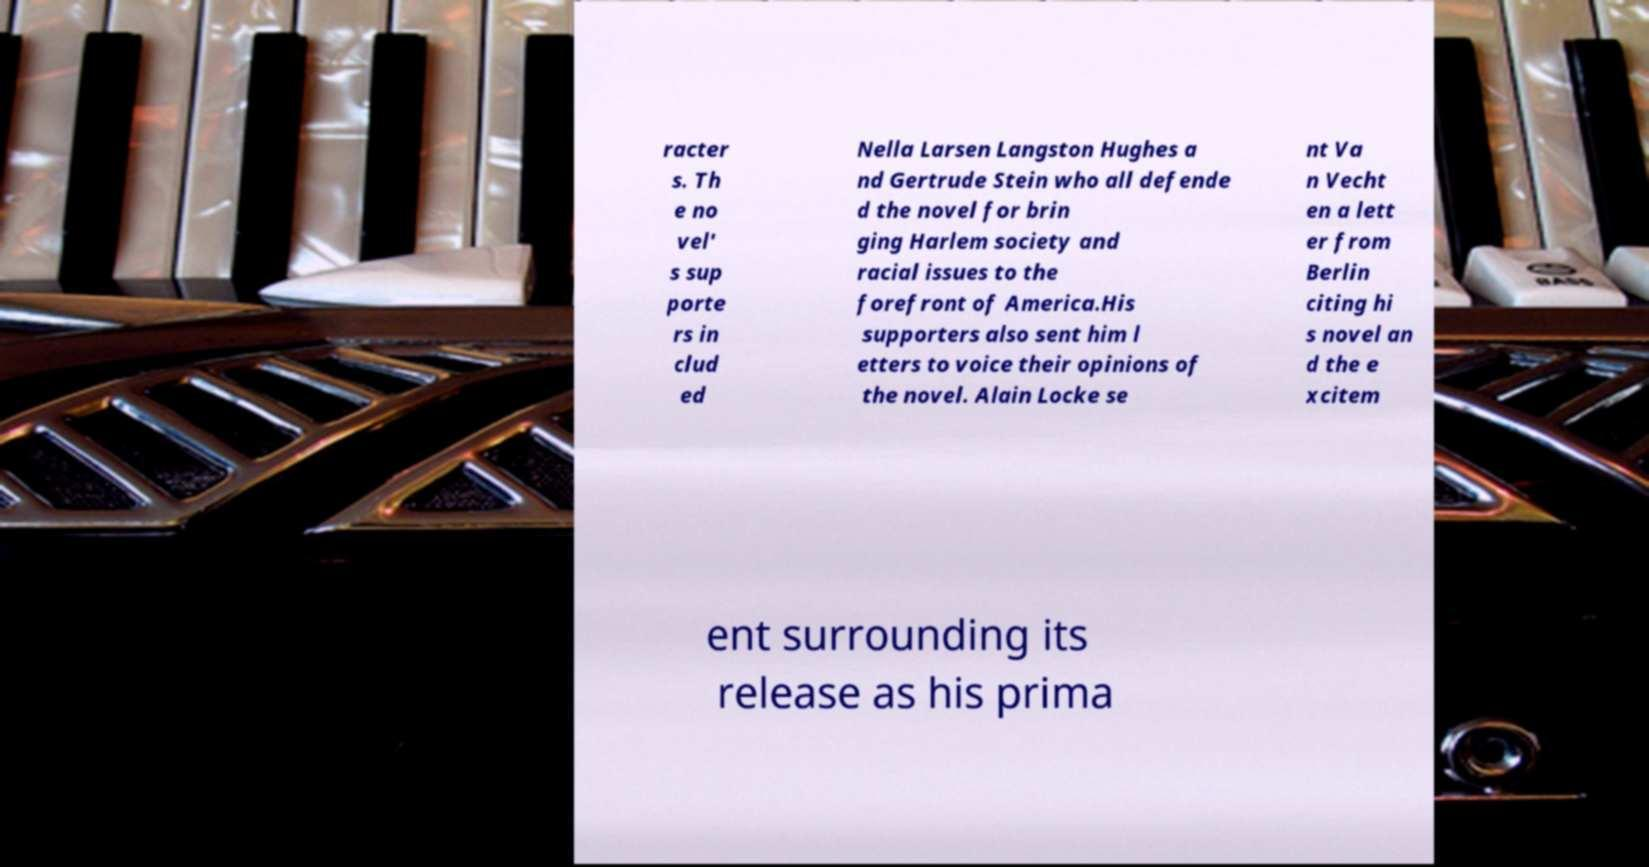Can you accurately transcribe the text from the provided image for me? racter s. Th e no vel' s sup porte rs in clud ed Nella Larsen Langston Hughes a nd Gertrude Stein who all defende d the novel for brin ging Harlem society and racial issues to the forefront of America.His supporters also sent him l etters to voice their opinions of the novel. Alain Locke se nt Va n Vecht en a lett er from Berlin citing hi s novel an d the e xcitem ent surrounding its release as his prima 